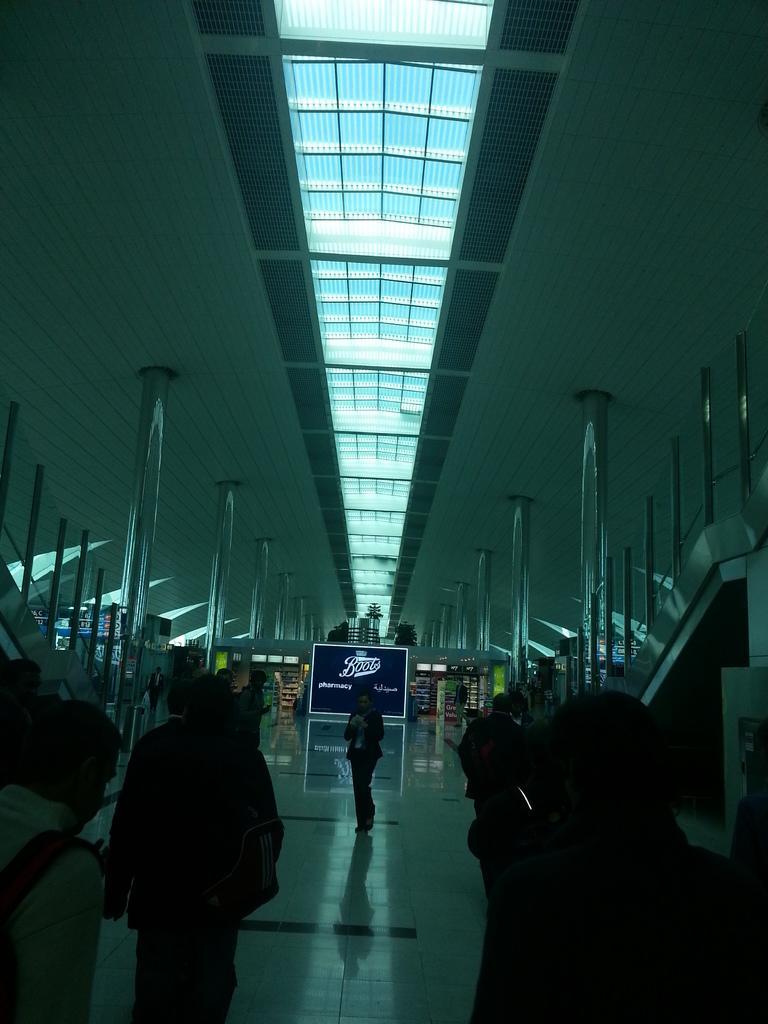In one or two sentences, can you explain what this image depicts? In this image, there are a few people. We can see the ground. We can see some shelves with objects. There are a few pillars and boards with text. We can also see the shed at the top. We can see the railing on the left and right. 